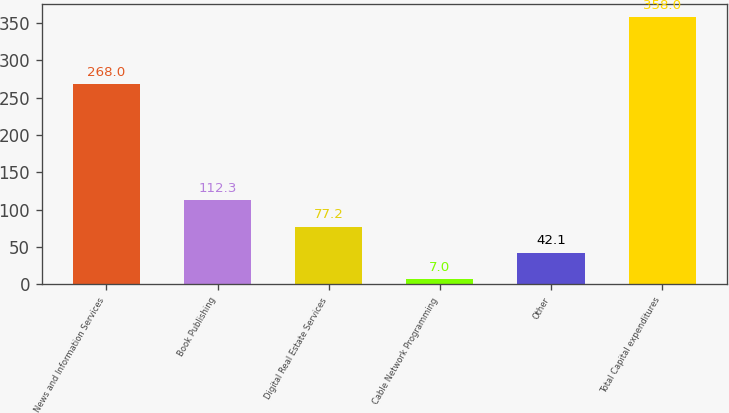Convert chart. <chart><loc_0><loc_0><loc_500><loc_500><bar_chart><fcel>News and Information Services<fcel>Book Publishing<fcel>Digital Real Estate Services<fcel>Cable Network Programming<fcel>Other<fcel>Total Capital expenditures<nl><fcel>268<fcel>112.3<fcel>77.2<fcel>7<fcel>42.1<fcel>358<nl></chart> 